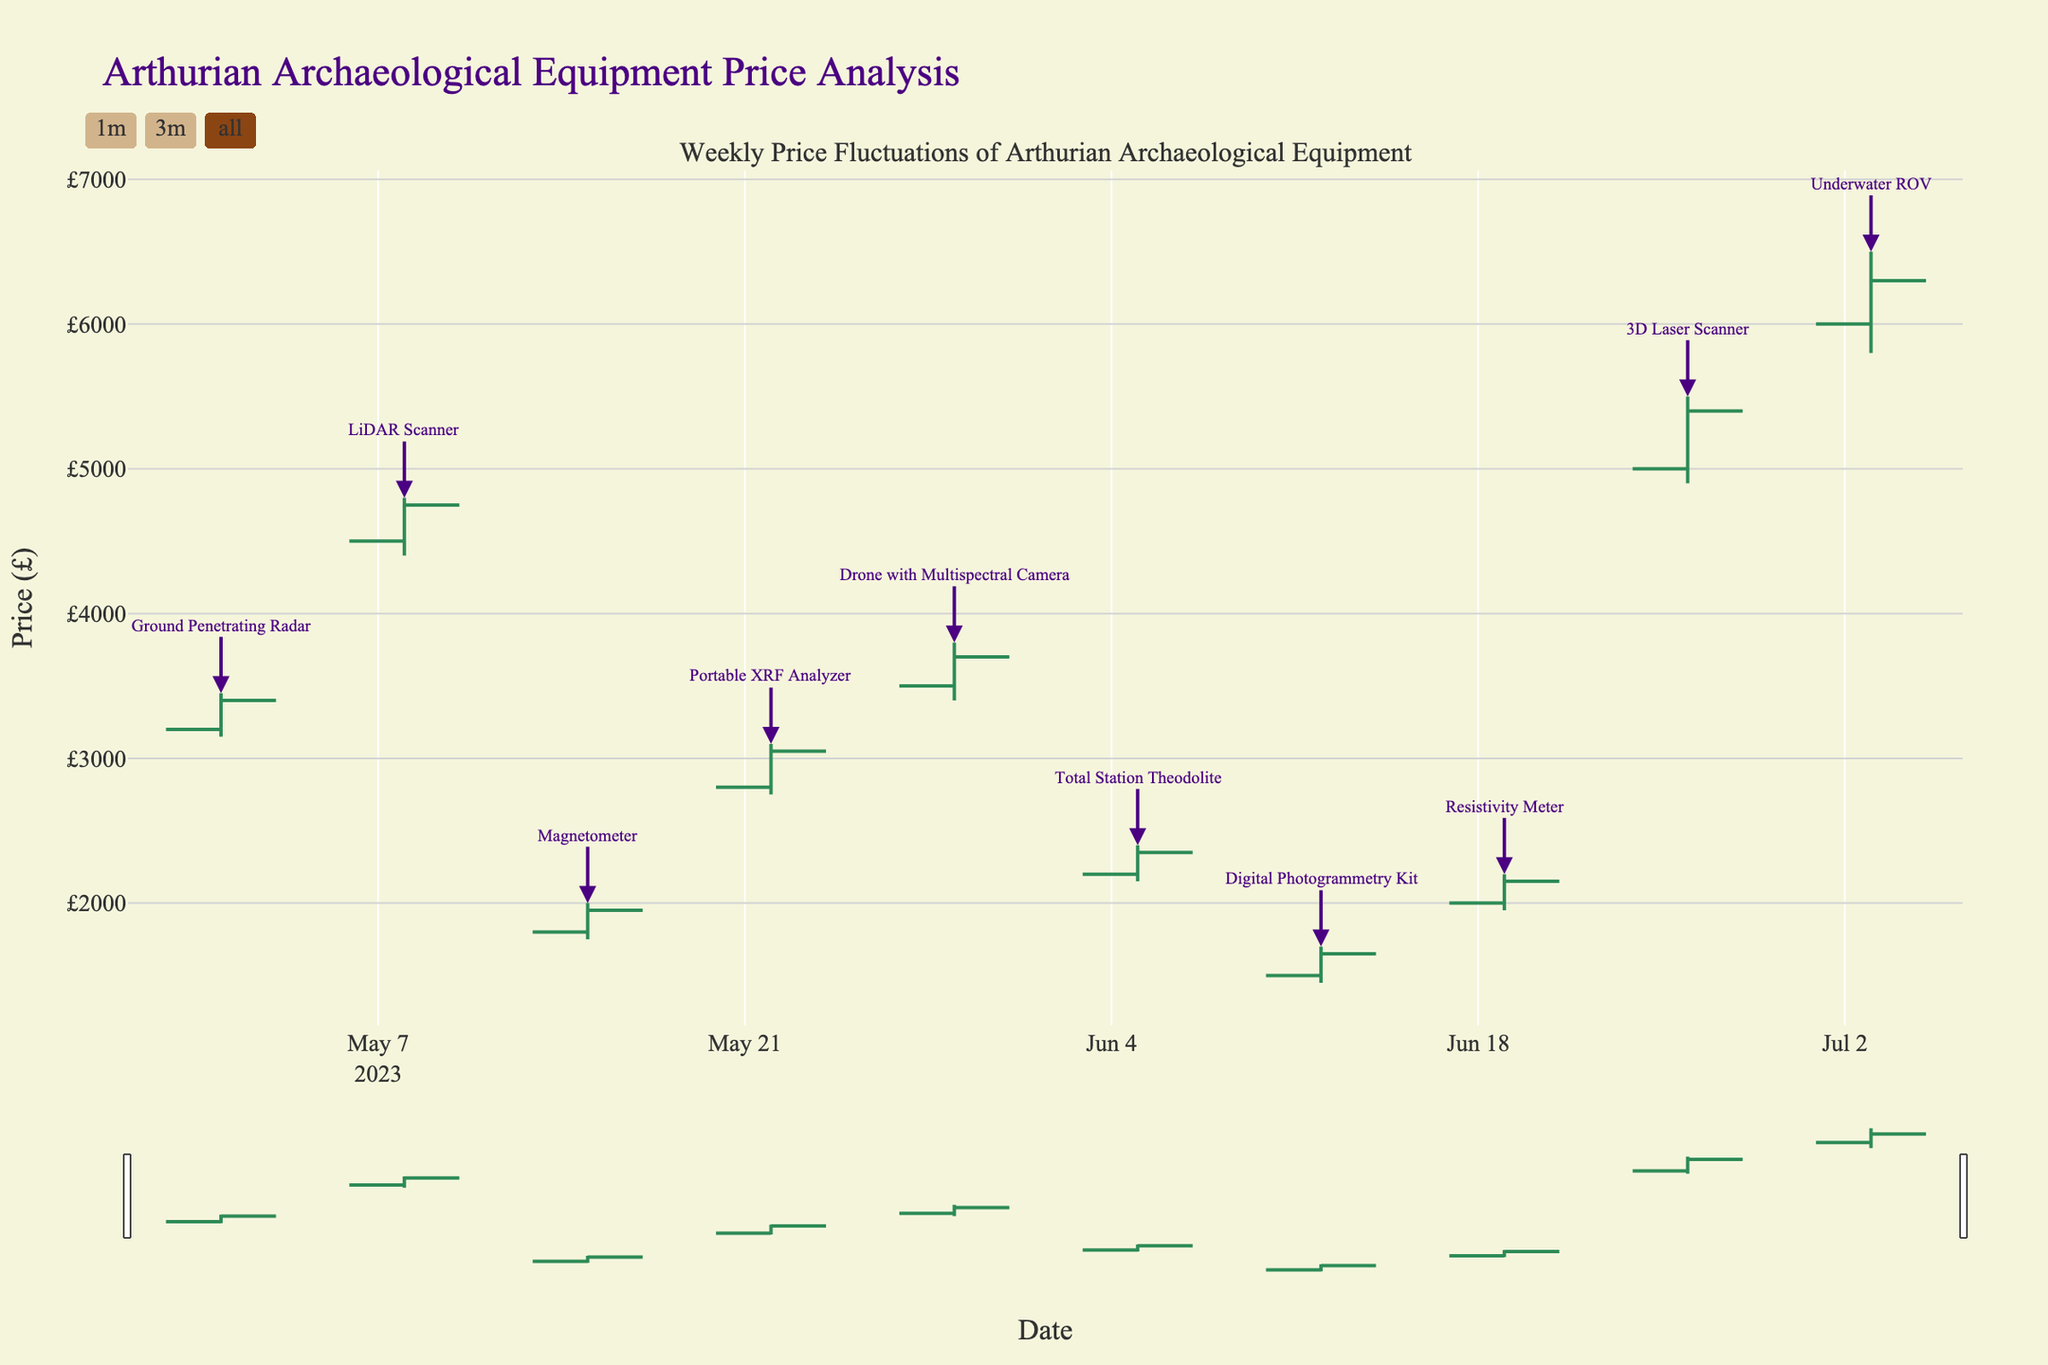How many different types of equipment are listed? The title of the plot mentions "Weekly Price Fluctuations of Arthurian Archaeological Equipment," suggesting multiple equipment types. By counting the unique equipment labels in the annotations, we can see there are 10 different types of equipment.
Answer: 10 What is the maximum price of the Underwater ROV? Locate the OHLC data point for the week of July 3, corresponding to the Underwater ROV. The maximum price is given by the "High" value for that date. It shows the highest value as £6500.
Answer: £6500 Which equipment had the highest closing price in the entire timeframe? By comparing all the "Close" values across the different weeks, the highest closing price is £6300, corresponding to the Underwater ROV on July 3.
Answer: Underwater ROV What's the price range (difference between the highest and the lowest price) of the 3D Laser Scanner? For the week of June 26, look at the "High" and "Low" values for the 3D Laser Scanner. The high price is £5500, and the low price is £4900. Subtract the low from the high to get the difference: £5500 - £4900 = £600.
Answer: £600 Which equipment experienced the greatest price increase from opening to closing within a single week? To find this, calculate the difference between the open and close prices for each week and identify the largest positive difference. For the Ground Penetrating Radar on May 1: £3400 - £3200 = £200. Comparing all the differences: LiDAR Scanner, May 8: £4750 - £4500 = £250; Magnetometer, May 15: £1950 - £1800 = £150; Portable XRF Analyzer, May 22: £3050 - £2800 = £250; Drone, May 29: £3700 - £3500 = £200; Theodolite, June 5: £2350 - £2200 = £150; Photogrammetry, June 12: £1650 - £1500 = £150; Resistivity Meter, June 19: £2150 - £2000 = £150; Laser Scanner, June 26: £5400 - £5000 = £400; ROV, July 3: £6300 - £6000 = £300. The greatest increase is for the 3D Laser Scanner at £400.
Answer: 3D Laser Scanner Which two equipment types had a closing price of £2150? By checking the close values, observe that both the Resistivity Meter (June 19) and the Total Station Theodolite (June 5) have a closing price of £2150.
Answer: Resistivity Meter, Total Station Theodolite On which date did the Portable XRF Analyzer have a significant price fluctuation, and what was the fluctuation? For the Portable XRF Analyzer in the week of May 22, the price fluctuation can be assessed by finding the range between the highest and lowest prices. The high was £3100, and the low was £2750. Calculate the difference: £3100 - £2750 = £350.
Answer: May 22, £350 What was the average closing price of the Digital Photogrammetry Kit and the Magnetometer? Locate the closing prices of both equipment. For the week of June 12, the Digital Photogrammetry Kit closed at £1650. For the week of May 15, the Magnetometer closed at £1950. Calculate the average: (£1650 + £1950) / 2 = £1800.
Answer: £1800 Between the Ground Penetrating Radar and the Drone with Multispectral Camera, which had a higher opening price, and what was it? For the Ground Penetrating Radar (May 1), the opening price was £3200. For the Drone (May 29), the opening price was £3500. Comparing the two, the Drone had a higher opening price at £3500.
Answer: Drone with Multispectral Camera, £3500 Was there any equipment that didn't have an increasing trend from opening to closing price? If so, name one. An increasing trend is noted when the closing price is higher than the opening price. By checking each equipment’s open and close values, observe that the Ground Penetrating Radar, Digital Photogrammetry Kit, Magnetometer, and others have increasing trends. The LiDAR Scanner (May 8) does not, with prices opening at £4500 and closing at £4750, indicating a decreasing trend. However, this interpretation may vary according to exact data, typically requiring comparison against raw data.
Answer: LiDAR Scanner 